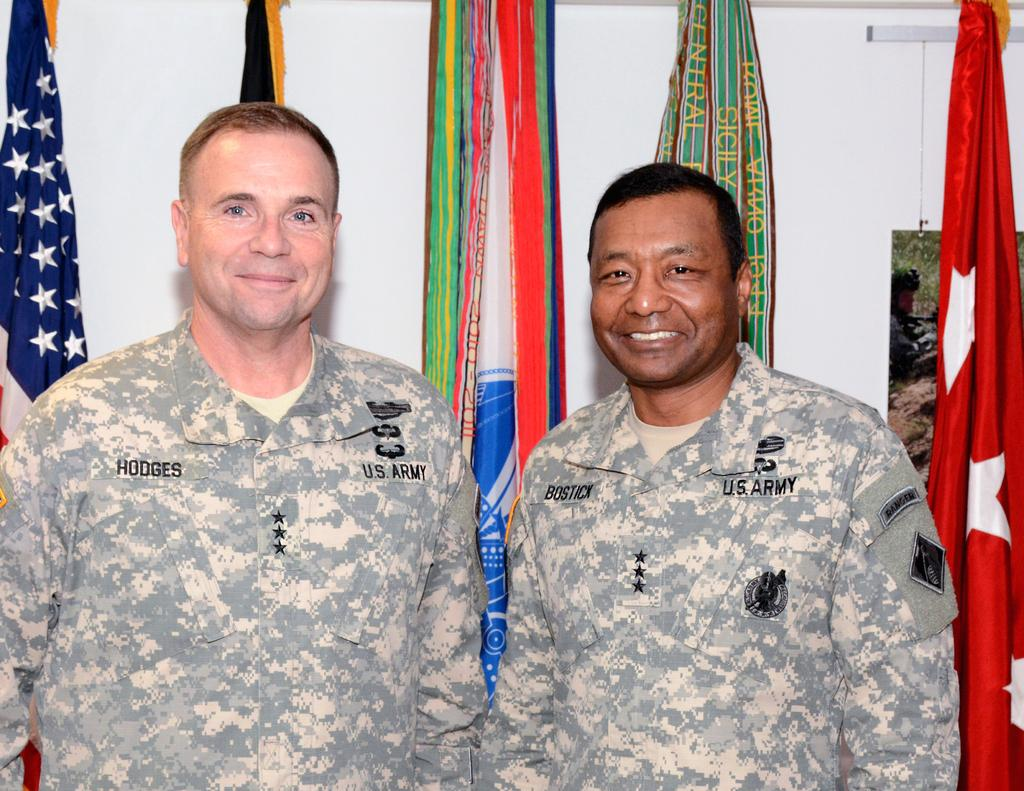How many people are in the image? There are two men in the image. What expressions do the men have? Both men are smiling. What can be seen behind the men? There are flags visible behind the men. What is in the background of the image? There is a wall in the background of the image. What type of heat source is being used for breakfast in the image? There is: There is no heat source or breakfast present in the image. What kind of rock can be seen in the image? There is no rock visible in the image. 